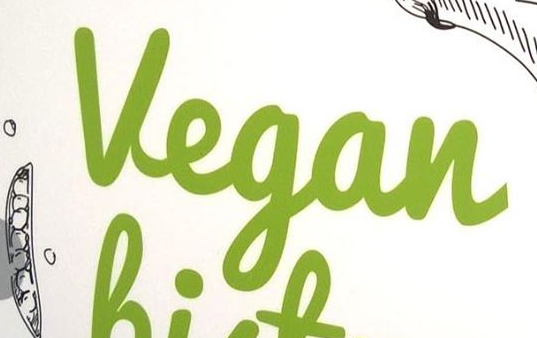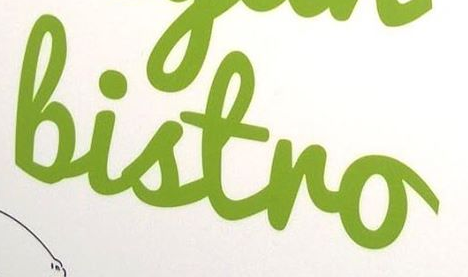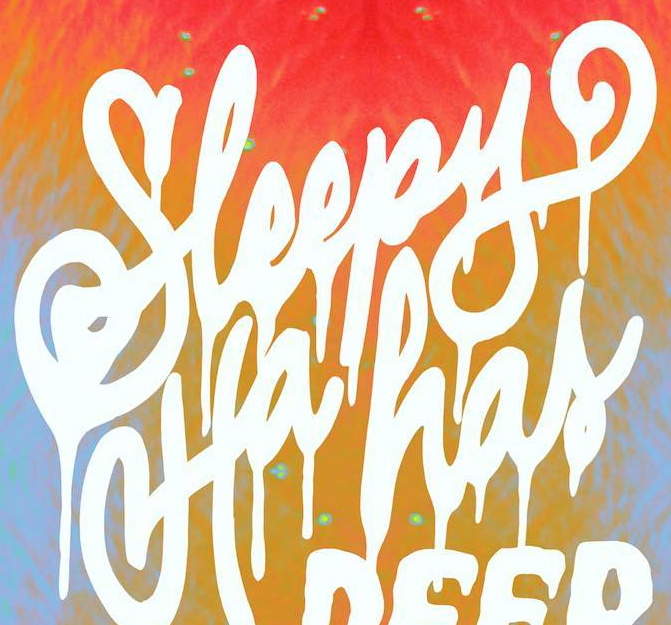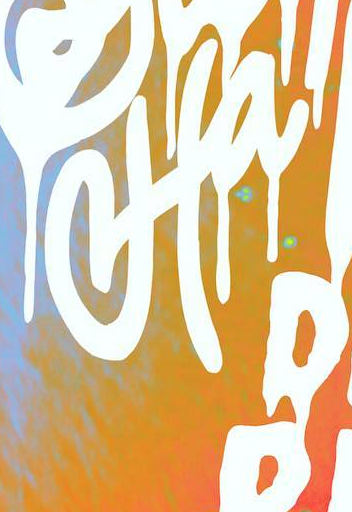What words can you see in these images in sequence, separated by a semicolon? Vegan; Bistro; Sleepy; Ha 